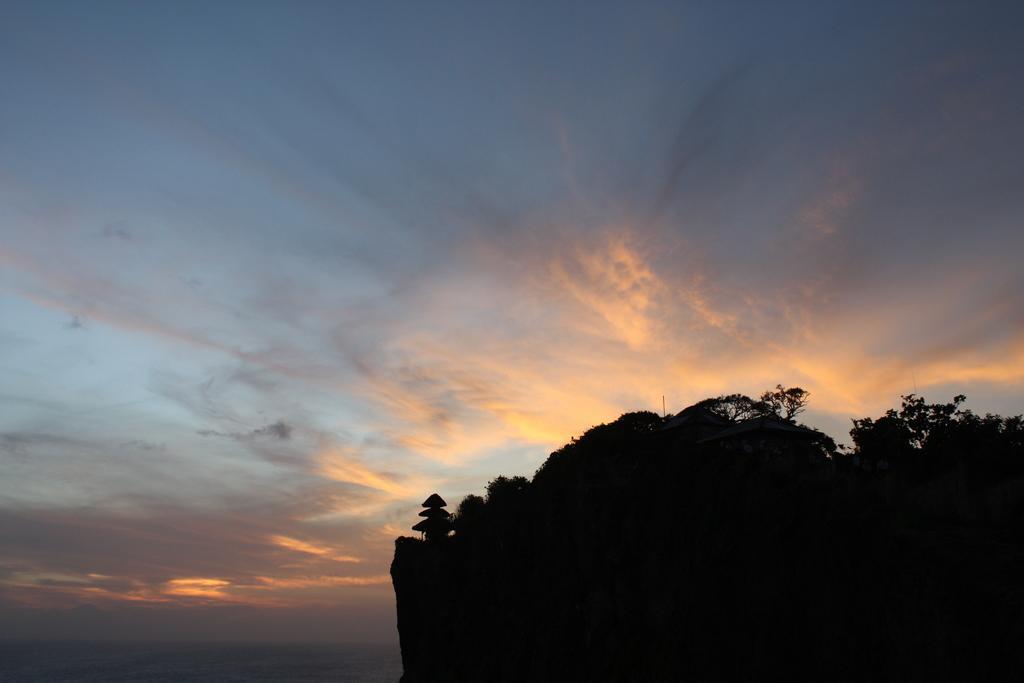Could you give a brief overview of what you see in this image? On the right side, there are trees on a mountain. In the background, there are clouds in the blue sky. 